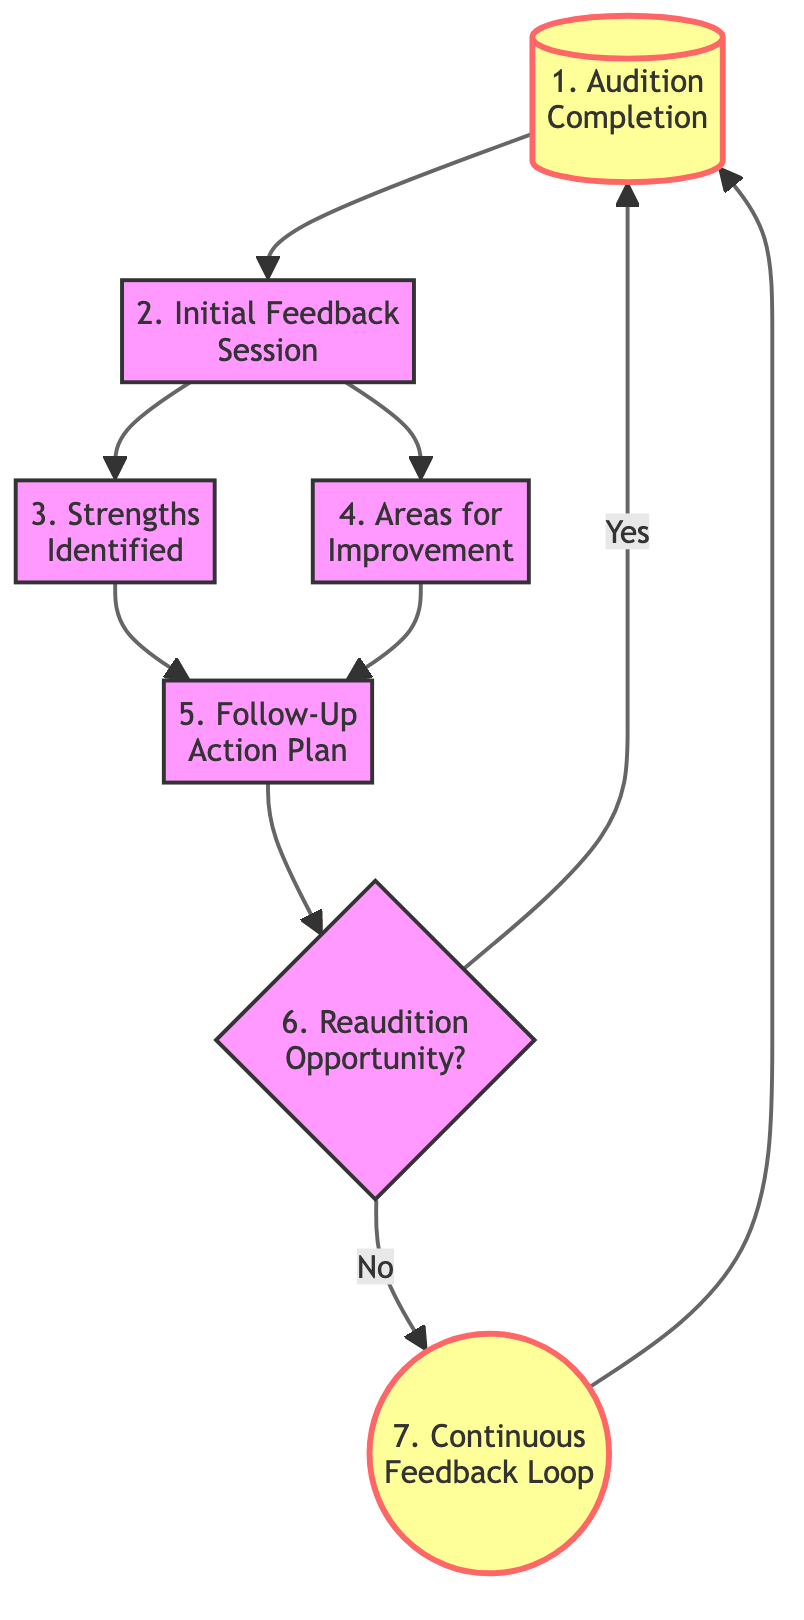What is the first step in the feedback loop? The first step in the diagram is "Audition Completion," which clearly indicates that the process begins here after the young actor finishes the audition.
Answer: Audition Completion How many nodes are in this flow chart? By counting each represented action and decision in the flow chart, we determine there are seven distinct nodes, including both actions and decision points.
Answer: 7 What feedback is given immediately after the audition? The feedback given immediately after the audition is categorized as "Initial Feedback Session," which suggests an immediate review of the actor's performance.
Answer: Initial Feedback Session What happens if there is no re-audition opportunity? In the flow chart, if there is no re-audition opportunity, the process continues to "Continuous Feedback Loop," indicating ongoing evaluation and growth for the actor despite not having another audition immediately.
Answer: Continuous Feedback Loop Which step involves identifying positive aspects of the actor's performance? The step that involves identifying positive aspects of the actor's performance is titled "Strengths Identified," which indicates that this feedback is a focus area after initial feedback is given.
Answer: Strengths Identified What action follows after identifying both strengths and areas for improvement? Following the identification of both strengths and areas for improvement, the next action is to develop a "Follow-Up Action Plan," where the actor can decide how to use the feedback received.
Answer: Follow-Up Action Plan What decision is made after the follow-up action plan is created? After creating the follow-up action plan, the decision point is whether there will be a "Reaudition Opportunity," which leads to either initiating the audition process again or moving to the continuous feedback stage.
Answer: Reaudition Opportunity What are the consequences of having a re-audition opportunity? If there is a re-audition opportunity, the process continues by looping back to "Audition Completion," allowing the actor to audition again and potentially receive further feedback.
Answer: Audition Completion 